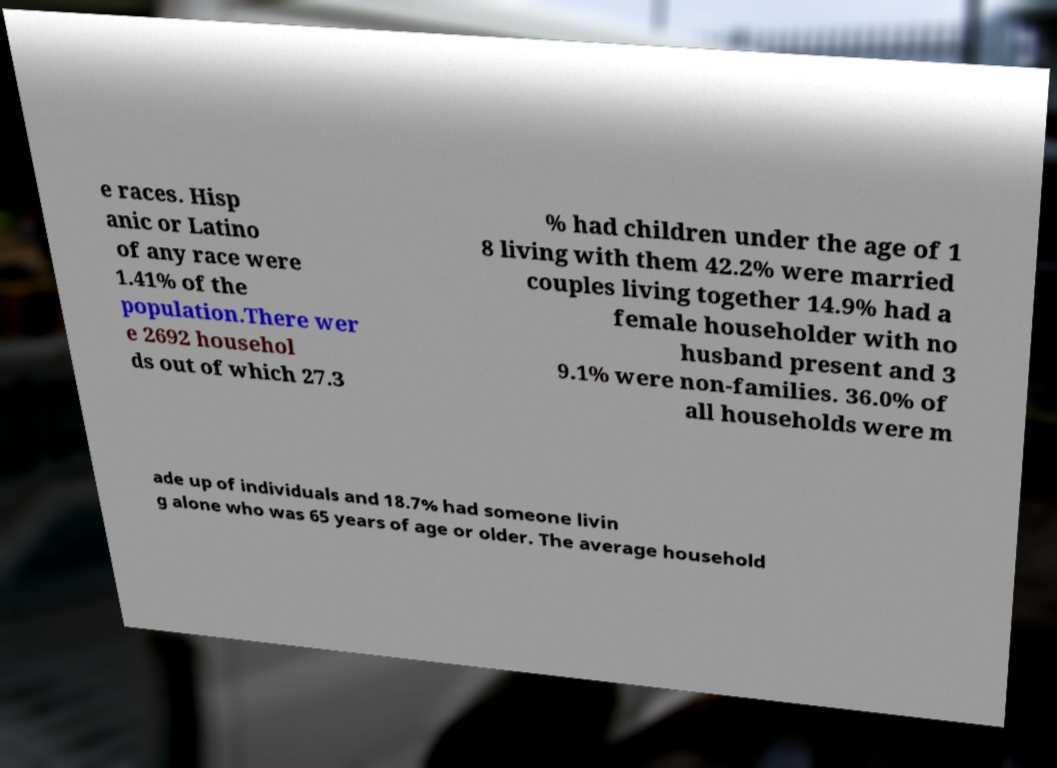What messages or text are displayed in this image? I need them in a readable, typed format. e races. Hisp anic or Latino of any race were 1.41% of the population.There wer e 2692 househol ds out of which 27.3 % had children under the age of 1 8 living with them 42.2% were married couples living together 14.9% had a female householder with no husband present and 3 9.1% were non-families. 36.0% of all households were m ade up of individuals and 18.7% had someone livin g alone who was 65 years of age or older. The average household 